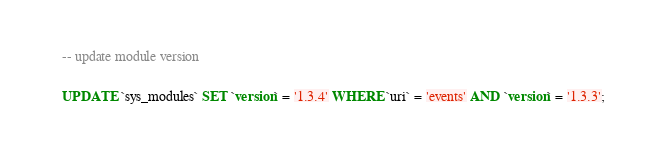<code> <loc_0><loc_0><loc_500><loc_500><_SQL_>

-- update module version

UPDATE `sys_modules` SET `version` = '1.3.4' WHERE `uri` = 'events' AND `version` = '1.3.3';

</code> 